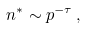<formula> <loc_0><loc_0><loc_500><loc_500>n ^ { * } \sim p ^ { - \tau } \, ,</formula> 